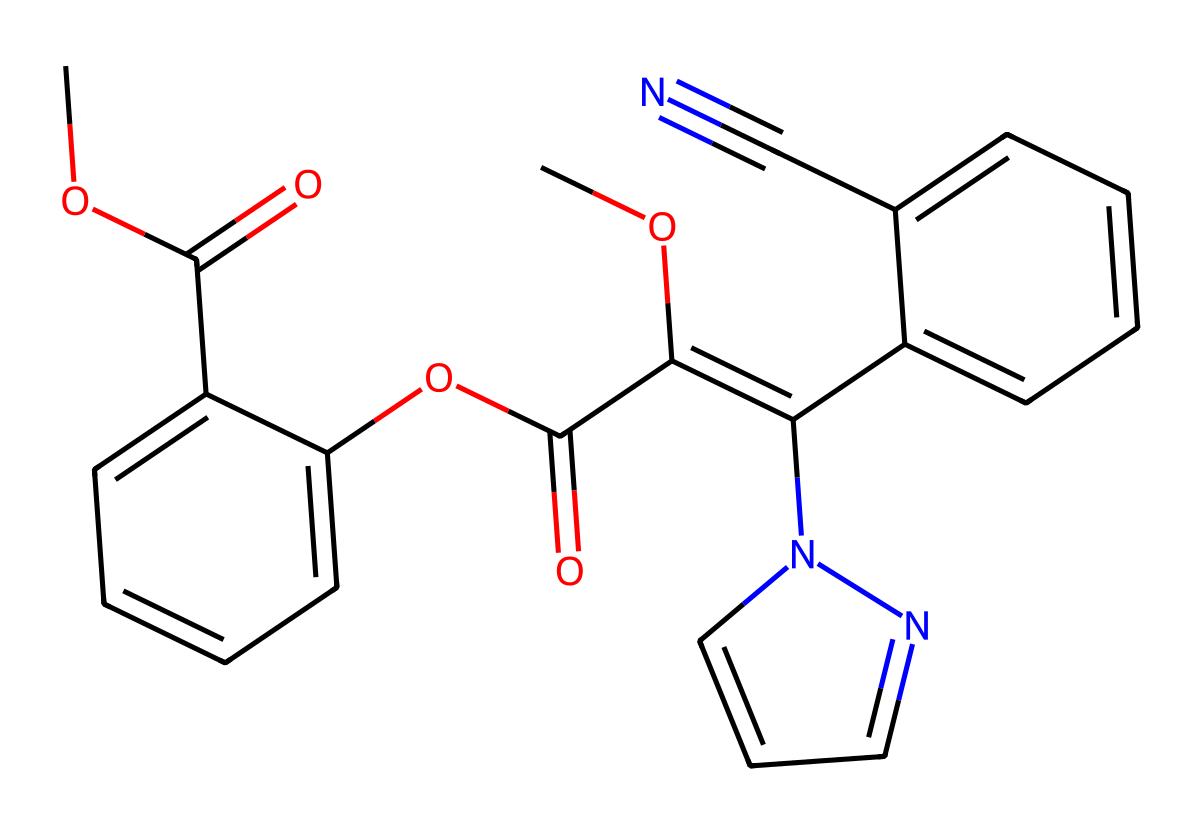What is the molecular formula of azoxystrobin? To determine the molecular formula, we need to count the number of each type of atom in the given SMILES representation. The chemical contains carbon (C), hydrogen (H), nitrogen (N), and oxygen (O). By counting the atoms, we find there are 21 carbon atoms, 24 hydrogen atoms, 4 nitrogen atoms, and 6 oxygen atoms. Thus, the molecular formula is C21H24N4O6.
Answer: C21H24N4O6 How many rings are present in the chemical structure of azoxystrobin? In analyzing the chemical structure from the SMILES, we can identify the cyclic components. There are two benzene rings (six-membered aromatic rings) and one additional five-membered ring resulting in three rings in total.
Answer: 3 What functional groups are present in azoxystrobin? By examining the SMILES notation, we can identify several functional groups: esters (due to the C(=O)O notation), aromatic rings, and a cyano group (C#N). These are characteristic of the structure of azoxystrobin.
Answer: ester, aromatic, cyano What type of chemical bond connects the carbon and nitrogen atoms in azoxystrobin? Looking at the bonding in the structure, we see that the carbon (C) and nitrogen (N) atoms are connected by single and double bonds. In particular, the C=N double bond can be observed.
Answer: double bond What is the significance of the cyano group in azoxystrobin? The cyano group (C#N) plays a critical role in the fungicide's activity and function within its chemical structure. It contributes to the overall stability and biological activity of the molecule. Hence, the cyano group enhances its efficacy as a fungicide.
Answer: biological activity Which part of azoxystrobin contributes to its function as a fungicide? The presence of the aromatic rings and the cyano group in the structure are critical for its fungicidal activity. These components are integral to how the molecule interacts with fungal pathogens and inhibits their growth.
Answer: aromatic rings and cyano group 